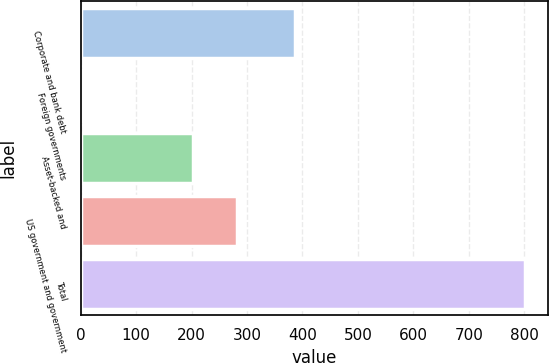Convert chart to OTSL. <chart><loc_0><loc_0><loc_500><loc_500><bar_chart><fcel>Corporate and bank debt<fcel>Foreign governments<fcel>Asset-backed and<fcel>US government and government<fcel>Total<nl><fcel>386<fcel>5<fcel>202<fcel>281.7<fcel>802<nl></chart> 